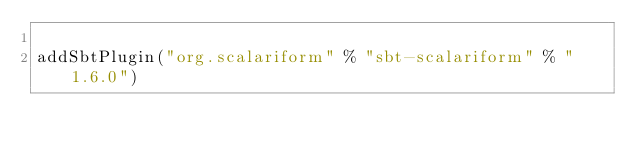<code> <loc_0><loc_0><loc_500><loc_500><_Scala_>
addSbtPlugin("org.scalariform" % "sbt-scalariform" % "1.6.0")</code> 